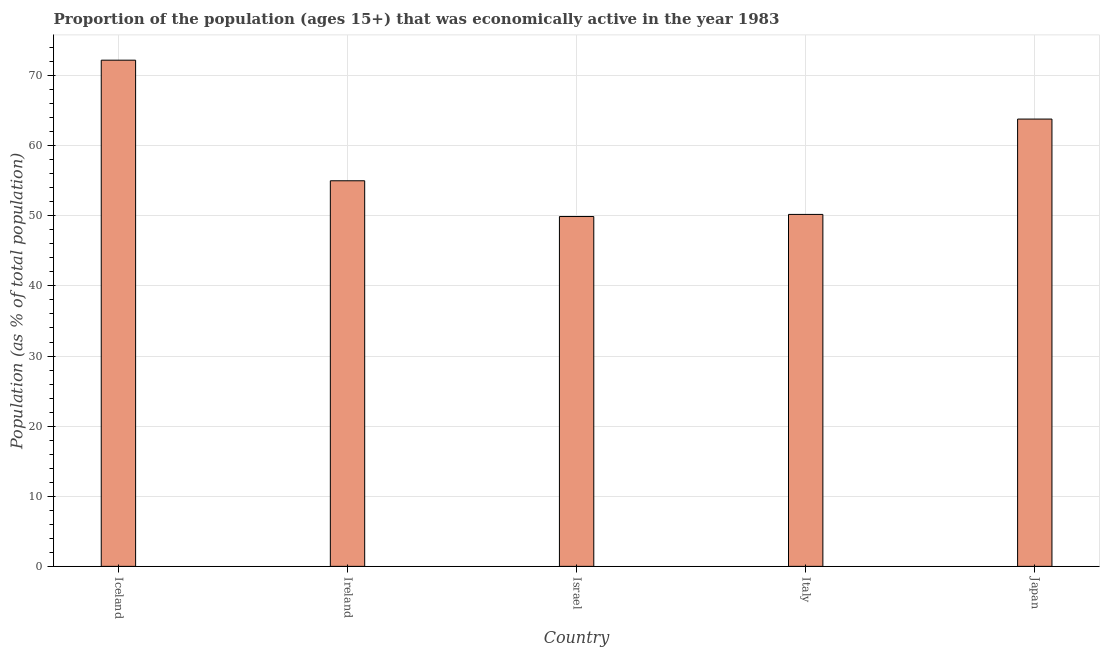Does the graph contain any zero values?
Your answer should be very brief. No. Does the graph contain grids?
Make the answer very short. Yes. What is the title of the graph?
Give a very brief answer. Proportion of the population (ages 15+) that was economically active in the year 1983. What is the label or title of the X-axis?
Give a very brief answer. Country. What is the label or title of the Y-axis?
Your answer should be very brief. Population (as % of total population). What is the percentage of economically active population in Italy?
Provide a succinct answer. 50.2. Across all countries, what is the maximum percentage of economically active population?
Provide a succinct answer. 72.2. Across all countries, what is the minimum percentage of economically active population?
Keep it short and to the point. 49.9. In which country was the percentage of economically active population maximum?
Offer a terse response. Iceland. What is the sum of the percentage of economically active population?
Make the answer very short. 291.1. What is the difference between the percentage of economically active population in Ireland and Japan?
Your response must be concise. -8.8. What is the average percentage of economically active population per country?
Make the answer very short. 58.22. What is the median percentage of economically active population?
Your response must be concise. 55. What is the ratio of the percentage of economically active population in Iceland to that in Ireland?
Give a very brief answer. 1.31. Is the percentage of economically active population in Iceland less than that in Ireland?
Your answer should be very brief. No. Is the difference between the percentage of economically active population in Iceland and Ireland greater than the difference between any two countries?
Offer a terse response. No. What is the difference between the highest and the lowest percentage of economically active population?
Ensure brevity in your answer.  22.3. In how many countries, is the percentage of economically active population greater than the average percentage of economically active population taken over all countries?
Make the answer very short. 2. Are all the bars in the graph horizontal?
Your answer should be compact. No. What is the difference between two consecutive major ticks on the Y-axis?
Make the answer very short. 10. Are the values on the major ticks of Y-axis written in scientific E-notation?
Offer a very short reply. No. What is the Population (as % of total population) of Iceland?
Your answer should be very brief. 72.2. What is the Population (as % of total population) of Israel?
Keep it short and to the point. 49.9. What is the Population (as % of total population) of Italy?
Offer a terse response. 50.2. What is the Population (as % of total population) of Japan?
Your response must be concise. 63.8. What is the difference between the Population (as % of total population) in Iceland and Israel?
Provide a succinct answer. 22.3. What is the difference between the Population (as % of total population) in Iceland and Italy?
Your response must be concise. 22. What is the difference between the Population (as % of total population) in Ireland and Israel?
Offer a very short reply. 5.1. What is the difference between the Population (as % of total population) in Ireland and Japan?
Keep it short and to the point. -8.8. What is the difference between the Population (as % of total population) in Israel and Japan?
Provide a short and direct response. -13.9. What is the difference between the Population (as % of total population) in Italy and Japan?
Offer a very short reply. -13.6. What is the ratio of the Population (as % of total population) in Iceland to that in Ireland?
Your answer should be compact. 1.31. What is the ratio of the Population (as % of total population) in Iceland to that in Israel?
Provide a succinct answer. 1.45. What is the ratio of the Population (as % of total population) in Iceland to that in Italy?
Keep it short and to the point. 1.44. What is the ratio of the Population (as % of total population) in Iceland to that in Japan?
Your answer should be very brief. 1.13. What is the ratio of the Population (as % of total population) in Ireland to that in Israel?
Ensure brevity in your answer.  1.1. What is the ratio of the Population (as % of total population) in Ireland to that in Italy?
Offer a very short reply. 1.1. What is the ratio of the Population (as % of total population) in Ireland to that in Japan?
Your answer should be very brief. 0.86. What is the ratio of the Population (as % of total population) in Israel to that in Italy?
Give a very brief answer. 0.99. What is the ratio of the Population (as % of total population) in Israel to that in Japan?
Ensure brevity in your answer.  0.78. What is the ratio of the Population (as % of total population) in Italy to that in Japan?
Your answer should be very brief. 0.79. 